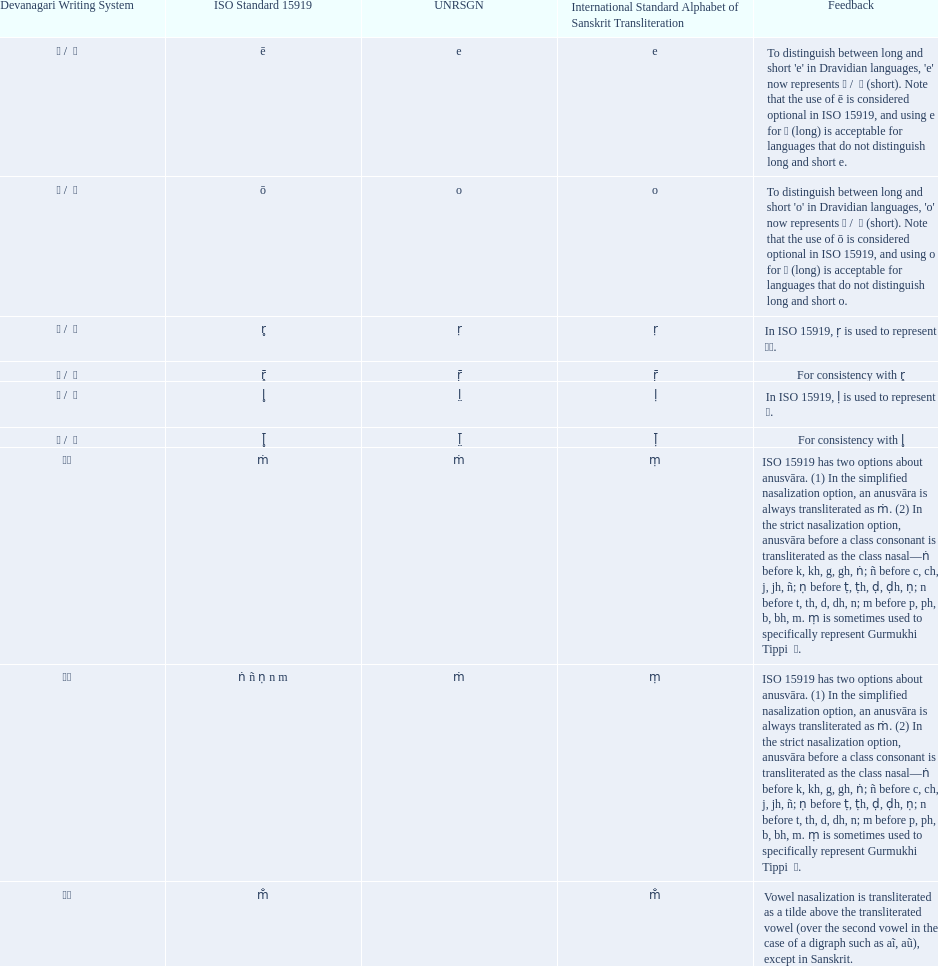What iast is listed before the o? E. Would you be able to parse every entry in this table? {'header': ['Devanagari Writing System', 'ISO Standard 15919', 'UNRSGN', 'International Standard Alphabet of Sanskrit Transliteration', 'Feedback'], 'rows': [['ए / \xa0े', 'ē', 'e', 'e', "To distinguish between long and short 'e' in Dravidian languages, 'e' now represents ऎ / \xa0ॆ (short). Note that the use of ē is considered optional in ISO 15919, and using e for ए (long) is acceptable for languages that do not distinguish long and short e."], ['ओ / \xa0ो', 'ō', 'o', 'o', "To distinguish between long and short 'o' in Dravidian languages, 'o' now represents ऒ / \xa0ॊ (short). Note that the use of ō is considered optional in ISO 15919, and using o for ओ (long) is acceptable for languages that do not distinguish long and short o."], ['ऋ / \xa0ृ', 'r̥', 'ṛ', 'ṛ', 'In ISO 15919, ṛ is used to represent ड़.'], ['ॠ / \xa0ॄ', 'r̥̄', 'ṝ', 'ṝ', 'For consistency with r̥'], ['ऌ / \xa0ॢ', 'l̥', 'l̤', 'ḷ', 'In ISO 15919, ḷ is used to represent ळ.'], ['ॡ / \xa0ॣ', 'l̥̄', 'l̤̄', 'ḹ', 'For consistency with l̥'], ['◌ं', 'ṁ', 'ṁ', 'ṃ', 'ISO 15919 has two options about anusvāra. (1) In the simplified nasalization option, an anusvāra is always transliterated as ṁ. (2) In the strict nasalization option, anusvāra before a class consonant is transliterated as the class nasal—ṅ before k, kh, g, gh, ṅ; ñ before c, ch, j, jh, ñ; ṇ before ṭ, ṭh, ḍ, ḍh, ṇ; n before t, th, d, dh, n; m before p, ph, b, bh, m. ṃ is sometimes used to specifically represent Gurmukhi Tippi \xa0ੰ.'], ['◌ं', 'ṅ ñ ṇ n m', 'ṁ', 'ṃ', 'ISO 15919 has two options about anusvāra. (1) In the simplified nasalization option, an anusvāra is always transliterated as ṁ. (2) In the strict nasalization option, anusvāra before a class consonant is transliterated as the class nasal—ṅ before k, kh, g, gh, ṅ; ñ before c, ch, j, jh, ñ; ṇ before ṭ, ṭh, ḍ, ḍh, ṇ; n before t, th, d, dh, n; m before p, ph, b, bh, m. ṃ is sometimes used to specifically represent Gurmukhi Tippi \xa0ੰ.'], ['◌ँ', 'm̐', '', 'm̐', 'Vowel nasalization is transliterated as a tilde above the transliterated vowel (over the second vowel in the case of a digraph such as aĩ, aũ), except in Sanskrit.']]} 